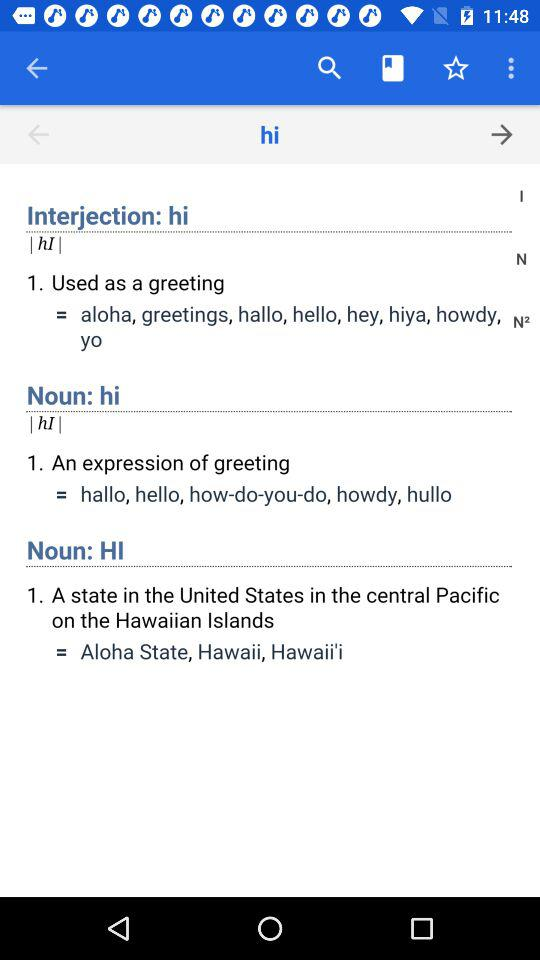Which word is being searched for its meaning? The word "hi" is being searched for its meaning. 